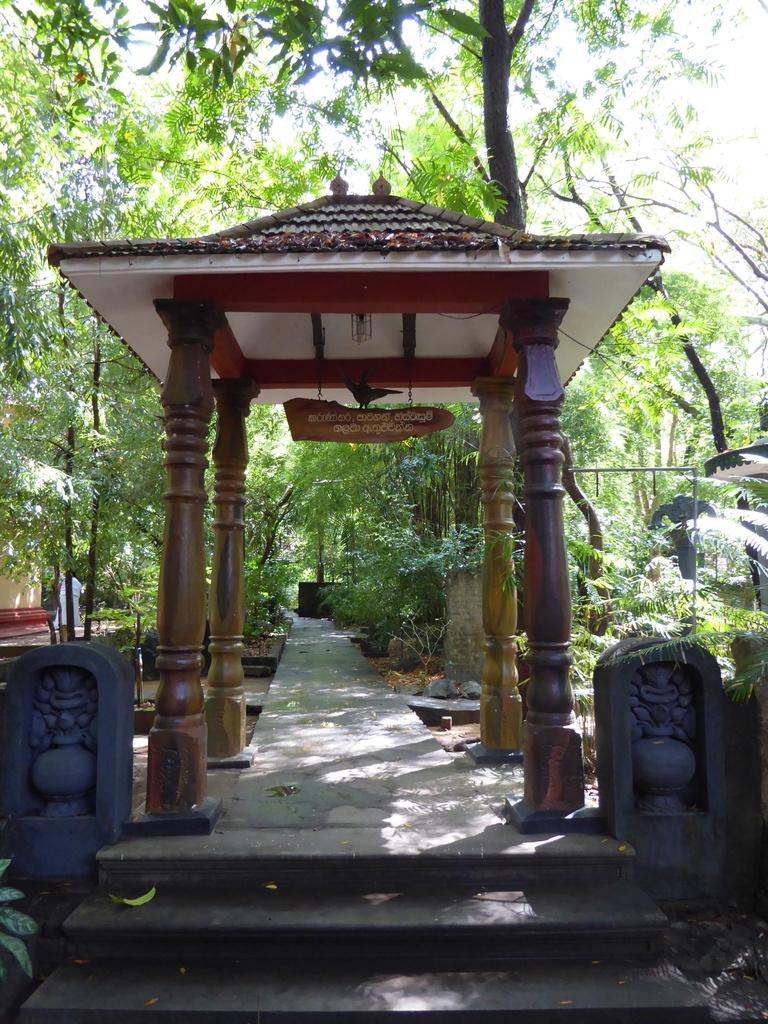What type of structure is depicted in the image? There is a roof with four pillars in the image, which suggests a building or shelter. What can be seen leading up to the structure? There is a pathway with stairs in the image. What type of vegetation is visible in the image? There are trees visible in the image. What part of the trees can be seen in the image? The bark of the trees is visible in the image. What is visible above the structure and trees? The sky is visible in the image. What type of haircut is the tree getting in the image? There is no haircut being given to the tree in the image; the focus is on the bark and the overall appearance of the tree. 